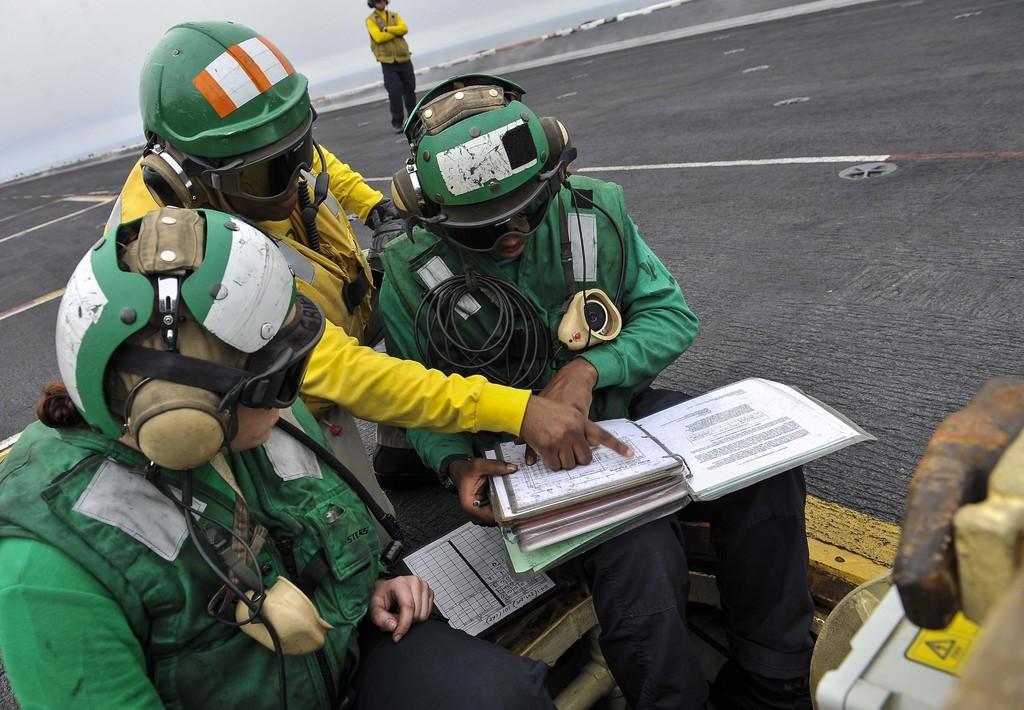Describe this image in one or two sentences. In this image there are three people who are wearing helmets, and they are wearing some costumes and one person is holding books and looking into books. And there is a paper, and in the bottom right hand corner there is some object and in the background there is walkway and one person is standing and some objects. At the top of the image there is sky. 